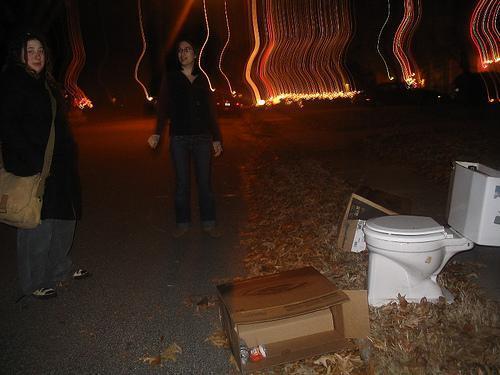How many people do you see?
Give a very brief answer. 2. How many toilet bowls do you see?
Give a very brief answer. 1. How many objects are in the box?
Give a very brief answer. 2. How many people are in the photo?
Give a very brief answer. 2. How many boats are in the water?
Give a very brief answer. 0. 